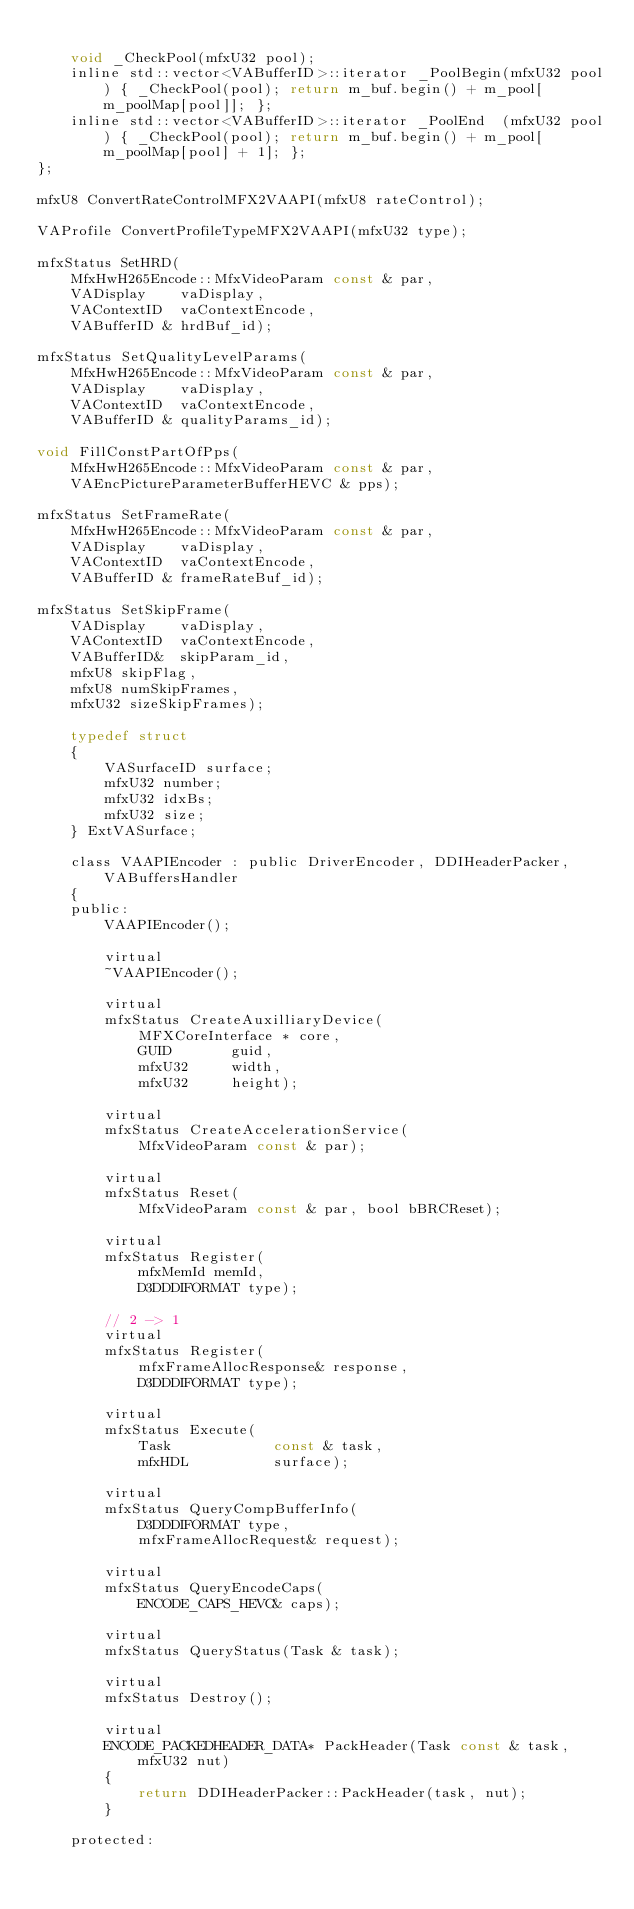<code> <loc_0><loc_0><loc_500><loc_500><_C_>
    void _CheckPool(mfxU32 pool);
    inline std::vector<VABufferID>::iterator _PoolBegin(mfxU32 pool) { _CheckPool(pool); return m_buf.begin() + m_pool[m_poolMap[pool]]; };
    inline std::vector<VABufferID>::iterator _PoolEnd  (mfxU32 pool) { _CheckPool(pool); return m_buf.begin() + m_pool[m_poolMap[pool] + 1]; };
};

mfxU8 ConvertRateControlMFX2VAAPI(mfxU8 rateControl);

VAProfile ConvertProfileTypeMFX2VAAPI(mfxU32 type);

mfxStatus SetHRD(
    MfxHwH265Encode::MfxVideoParam const & par,
    VADisplay    vaDisplay,
    VAContextID  vaContextEncode,
    VABufferID & hrdBuf_id);

mfxStatus SetQualityLevelParams(
    MfxHwH265Encode::MfxVideoParam const & par,
    VADisplay    vaDisplay,
    VAContextID  vaContextEncode,
    VABufferID & qualityParams_id);

void FillConstPartOfPps(
    MfxHwH265Encode::MfxVideoParam const & par,
    VAEncPictureParameterBufferHEVC & pps);

mfxStatus SetFrameRate(
    MfxHwH265Encode::MfxVideoParam const & par,
    VADisplay    vaDisplay,
    VAContextID  vaContextEncode,
    VABufferID & frameRateBuf_id);

mfxStatus SetSkipFrame(
    VADisplay    vaDisplay,
    VAContextID  vaContextEncode,
    VABufferID&  skipParam_id,
    mfxU8 skipFlag,
    mfxU8 numSkipFrames,
    mfxU32 sizeSkipFrames);

    typedef struct
    {
        VASurfaceID surface;
        mfxU32 number;
        mfxU32 idxBs;
        mfxU32 size;
    } ExtVASurface;

    class VAAPIEncoder : public DriverEncoder, DDIHeaderPacker, VABuffersHandler
    {
    public:
        VAAPIEncoder();

        virtual
        ~VAAPIEncoder();

        virtual
        mfxStatus CreateAuxilliaryDevice(
            MFXCoreInterface * core,
            GUID       guid,
            mfxU32     width,
            mfxU32     height);

        virtual
        mfxStatus CreateAccelerationService(
            MfxVideoParam const & par);

        virtual
        mfxStatus Reset(
            MfxVideoParam const & par, bool bBRCReset);

        virtual
        mfxStatus Register(
            mfxMemId memId,
            D3DDDIFORMAT type);

        // 2 -> 1
        virtual
        mfxStatus Register(
            mfxFrameAllocResponse& response,
            D3DDDIFORMAT type);

        virtual
        mfxStatus Execute(
            Task            const & task,
            mfxHDL          surface);

        virtual
        mfxStatus QueryCompBufferInfo(
            D3DDDIFORMAT type,
            mfxFrameAllocRequest& request);

        virtual
        mfxStatus QueryEncodeCaps(
            ENCODE_CAPS_HEVC& caps);

        virtual
        mfxStatus QueryStatus(Task & task);

        virtual
        mfxStatus Destroy();

        virtual
        ENCODE_PACKEDHEADER_DATA* PackHeader(Task const & task, mfxU32 nut)
        {
            return DDIHeaderPacker::PackHeader(task, nut);
        }

    protected:</code> 